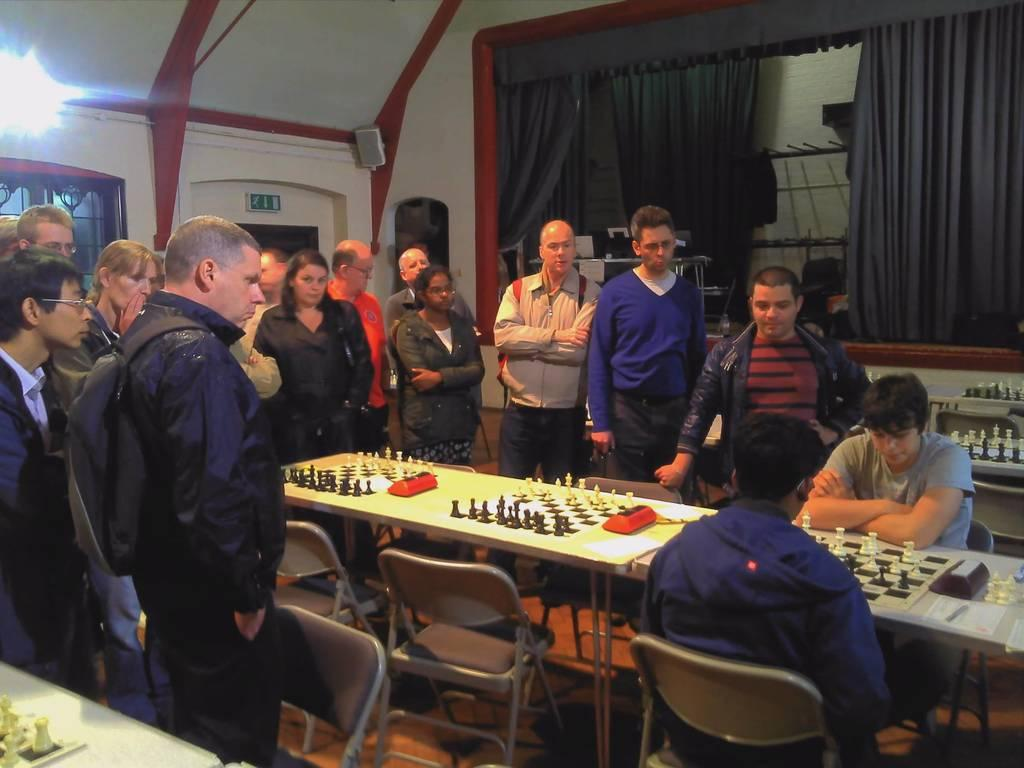What activity are the two people in the image engaged in? The two people in the image are playing a chess game. Are there any spectators in the image? Yes, other people are watching the match. What can be seen in the background of the image? There is a light and a curtain in the background. What type of stamp can be seen on the chessboard in the image? There is no stamp present on the chessboard in the image. How many pies are being served to the spectators in the image? There are no pies visible in the image. 